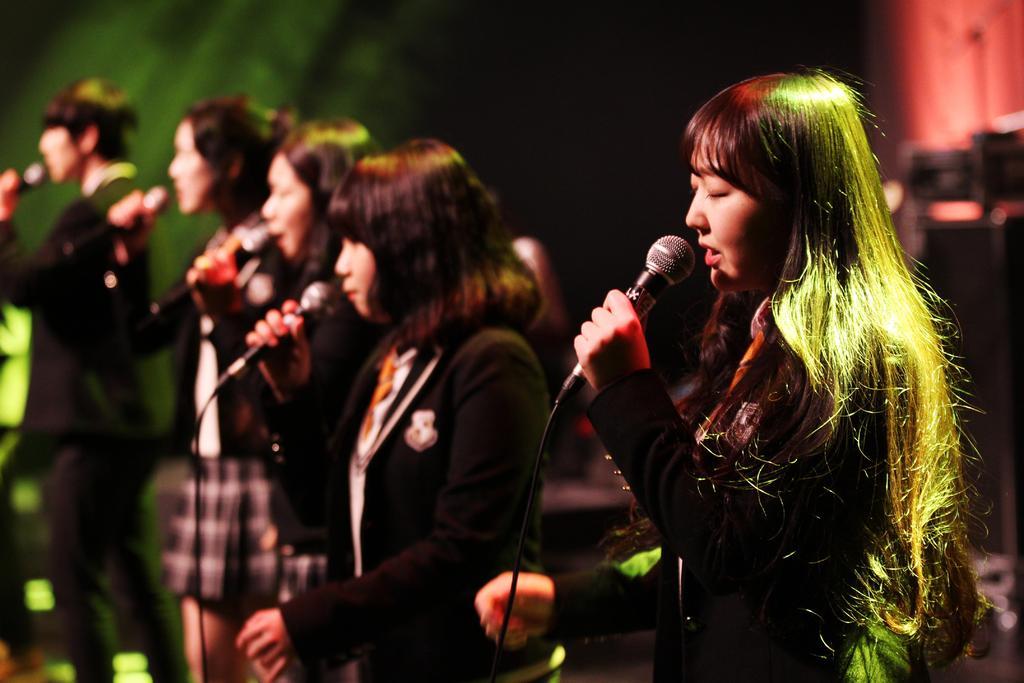In one or two sentences, can you explain what this image depicts? this picture shows few women and a man standing on the dais and singing with the help of the microphones 